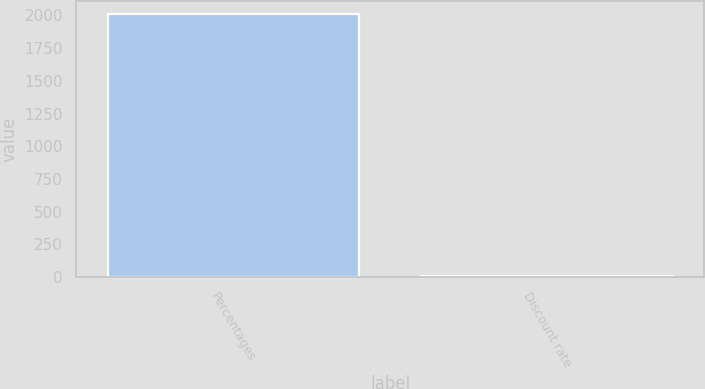Convert chart. <chart><loc_0><loc_0><loc_500><loc_500><bar_chart><fcel>Percentages<fcel>Discount rate<nl><fcel>2009<fcel>6.25<nl></chart> 